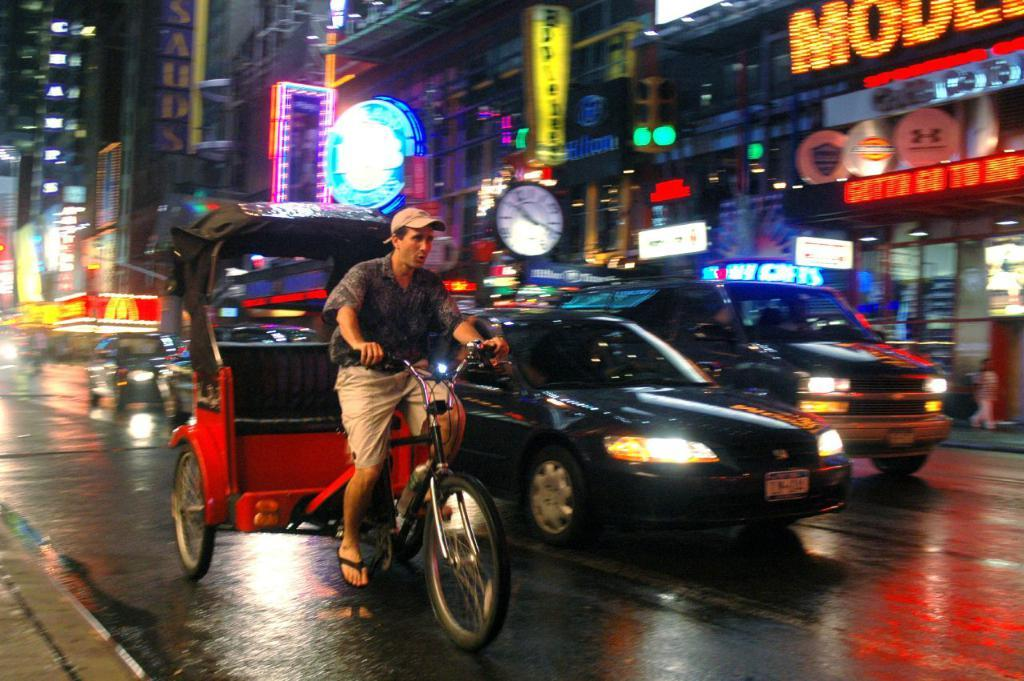<image>
Write a terse but informative summary of the picture. A bright lightbulb sign above the store reads Model. 